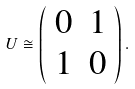Convert formula to latex. <formula><loc_0><loc_0><loc_500><loc_500>U \cong \left ( \begin{array} { c c } { 0 } & { 1 } \\ { 1 } & { 0 } \end{array} \right ) .</formula> 